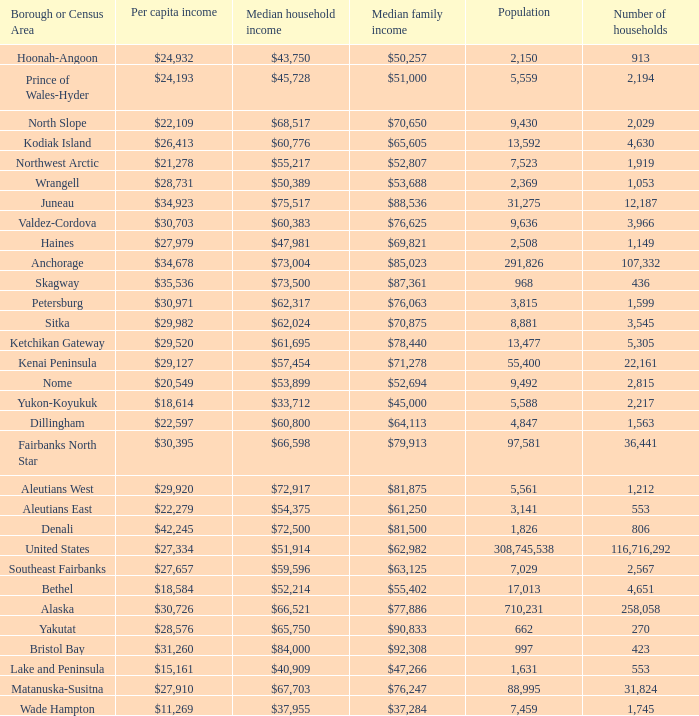What is the population of the area with a median family income of $71,278? 1.0. Could you parse the entire table as a dict? {'header': ['Borough or Census Area', 'Per capita income', 'Median household income', 'Median family income', 'Population', 'Number of households'], 'rows': [['Hoonah-Angoon', '$24,932', '$43,750', '$50,257', '2,150', '913'], ['Prince of Wales-Hyder', '$24,193', '$45,728', '$51,000', '5,559', '2,194'], ['North Slope', '$22,109', '$68,517', '$70,650', '9,430', '2,029'], ['Kodiak Island', '$26,413', '$60,776', '$65,605', '13,592', '4,630'], ['Northwest Arctic', '$21,278', '$55,217', '$52,807', '7,523', '1,919'], ['Wrangell', '$28,731', '$50,389', '$53,688', '2,369', '1,053'], ['Juneau', '$34,923', '$75,517', '$88,536', '31,275', '12,187'], ['Valdez-Cordova', '$30,703', '$60,383', '$76,625', '9,636', '3,966'], ['Haines', '$27,979', '$47,981', '$69,821', '2,508', '1,149'], ['Anchorage', '$34,678', '$73,004', '$85,023', '291,826', '107,332'], ['Skagway', '$35,536', '$73,500', '$87,361', '968', '436'], ['Petersburg', '$30,971', '$62,317', '$76,063', '3,815', '1,599'], ['Sitka', '$29,982', '$62,024', '$70,875', '8,881', '3,545'], ['Ketchikan Gateway', '$29,520', '$61,695', '$78,440', '13,477', '5,305'], ['Kenai Peninsula', '$29,127', '$57,454', '$71,278', '55,400', '22,161'], ['Nome', '$20,549', '$53,899', '$52,694', '9,492', '2,815'], ['Yukon-Koyukuk', '$18,614', '$33,712', '$45,000', '5,588', '2,217'], ['Dillingham', '$22,597', '$60,800', '$64,113', '4,847', '1,563'], ['Fairbanks North Star', '$30,395', '$66,598', '$79,913', '97,581', '36,441'], ['Aleutians West', '$29,920', '$72,917', '$81,875', '5,561', '1,212'], ['Aleutians East', '$22,279', '$54,375', '$61,250', '3,141', '553'], ['Denali', '$42,245', '$72,500', '$81,500', '1,826', '806'], ['United States', '$27,334', '$51,914', '$62,982', '308,745,538', '116,716,292'], ['Southeast Fairbanks', '$27,657', '$59,596', '$63,125', '7,029', '2,567'], ['Bethel', '$18,584', '$52,214', '$55,402', '17,013', '4,651'], ['Alaska', '$30,726', '$66,521', '$77,886', '710,231', '258,058'], ['Yakutat', '$28,576', '$65,750', '$90,833', '662', '270'], ['Bristol Bay', '$31,260', '$84,000', '$92,308', '997', '423'], ['Lake and Peninsula', '$15,161', '$40,909', '$47,266', '1,631', '553'], ['Matanuska-Susitna', '$27,910', '$67,703', '$76,247', '88,995', '31,824'], ['Wade Hampton', '$11,269', '$37,955', '$37,284', '7,459', '1,745']]} 